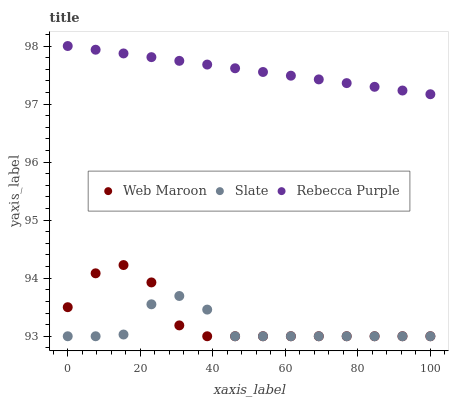Does Slate have the minimum area under the curve?
Answer yes or no. Yes. Does Rebecca Purple have the maximum area under the curve?
Answer yes or no. Yes. Does Web Maroon have the minimum area under the curve?
Answer yes or no. No. Does Web Maroon have the maximum area under the curve?
Answer yes or no. No. Is Rebecca Purple the smoothest?
Answer yes or no. Yes. Is Web Maroon the roughest?
Answer yes or no. Yes. Is Web Maroon the smoothest?
Answer yes or no. No. Is Rebecca Purple the roughest?
Answer yes or no. No. Does Slate have the lowest value?
Answer yes or no. Yes. Does Rebecca Purple have the lowest value?
Answer yes or no. No. Does Rebecca Purple have the highest value?
Answer yes or no. Yes. Does Web Maroon have the highest value?
Answer yes or no. No. Is Web Maroon less than Rebecca Purple?
Answer yes or no. Yes. Is Rebecca Purple greater than Slate?
Answer yes or no. Yes. Does Web Maroon intersect Slate?
Answer yes or no. Yes. Is Web Maroon less than Slate?
Answer yes or no. No. Is Web Maroon greater than Slate?
Answer yes or no. No. Does Web Maroon intersect Rebecca Purple?
Answer yes or no. No. 